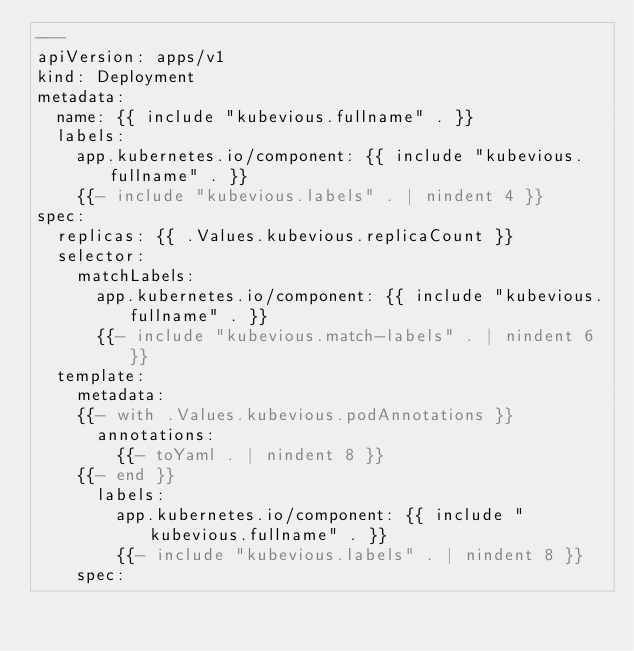Convert code to text. <code><loc_0><loc_0><loc_500><loc_500><_YAML_>---
apiVersion: apps/v1
kind: Deployment
metadata:
  name: {{ include "kubevious.fullname" . }}
  labels:
    app.kubernetes.io/component: {{ include "kubevious.fullname" . }}
    {{- include "kubevious.labels" . | nindent 4 }}
spec:
  replicas: {{ .Values.kubevious.replicaCount }}
  selector:
    matchLabels:
      app.kubernetes.io/component: {{ include "kubevious.fullname" . }}
      {{- include "kubevious.match-labels" . | nindent 6 }}
  template:
    metadata:
    {{- with .Values.kubevious.podAnnotations }}
      annotations:
        {{- toYaml . | nindent 8 }}
    {{- end }}
      labels:
        app.kubernetes.io/component: {{ include "kubevious.fullname" . }}
        {{- include "kubevious.labels" . | nindent 8 }}
    spec:</code> 